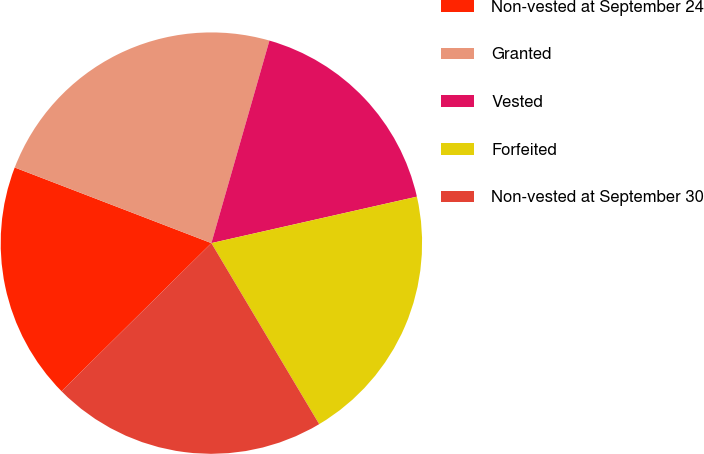Convert chart to OTSL. <chart><loc_0><loc_0><loc_500><loc_500><pie_chart><fcel>Non-vested at September 24<fcel>Granted<fcel>Vested<fcel>Forfeited<fcel>Non-vested at September 30<nl><fcel>18.25%<fcel>23.6%<fcel>17.02%<fcel>19.99%<fcel>21.14%<nl></chart> 